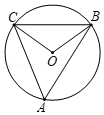Can you explain why the central angle is twice the inscribed angle? Certainly! In a circle, the central angle is formed by two radii, and an inscribed angle is formed by two chords that intersect at a point on the circle's edge. The arc subtended by both these angles is the same. According to the Circle Angle Theorem, the central angle is always twice the inscribed angle because it 'sees' the arc from a closer perspective, making the arc appear larger. Thus, for any inscribed angle, the central angle opposite that arc will measure twice as much. 